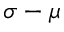Convert formula to latex. <formula><loc_0><loc_0><loc_500><loc_500>\sigma - \mu</formula> 